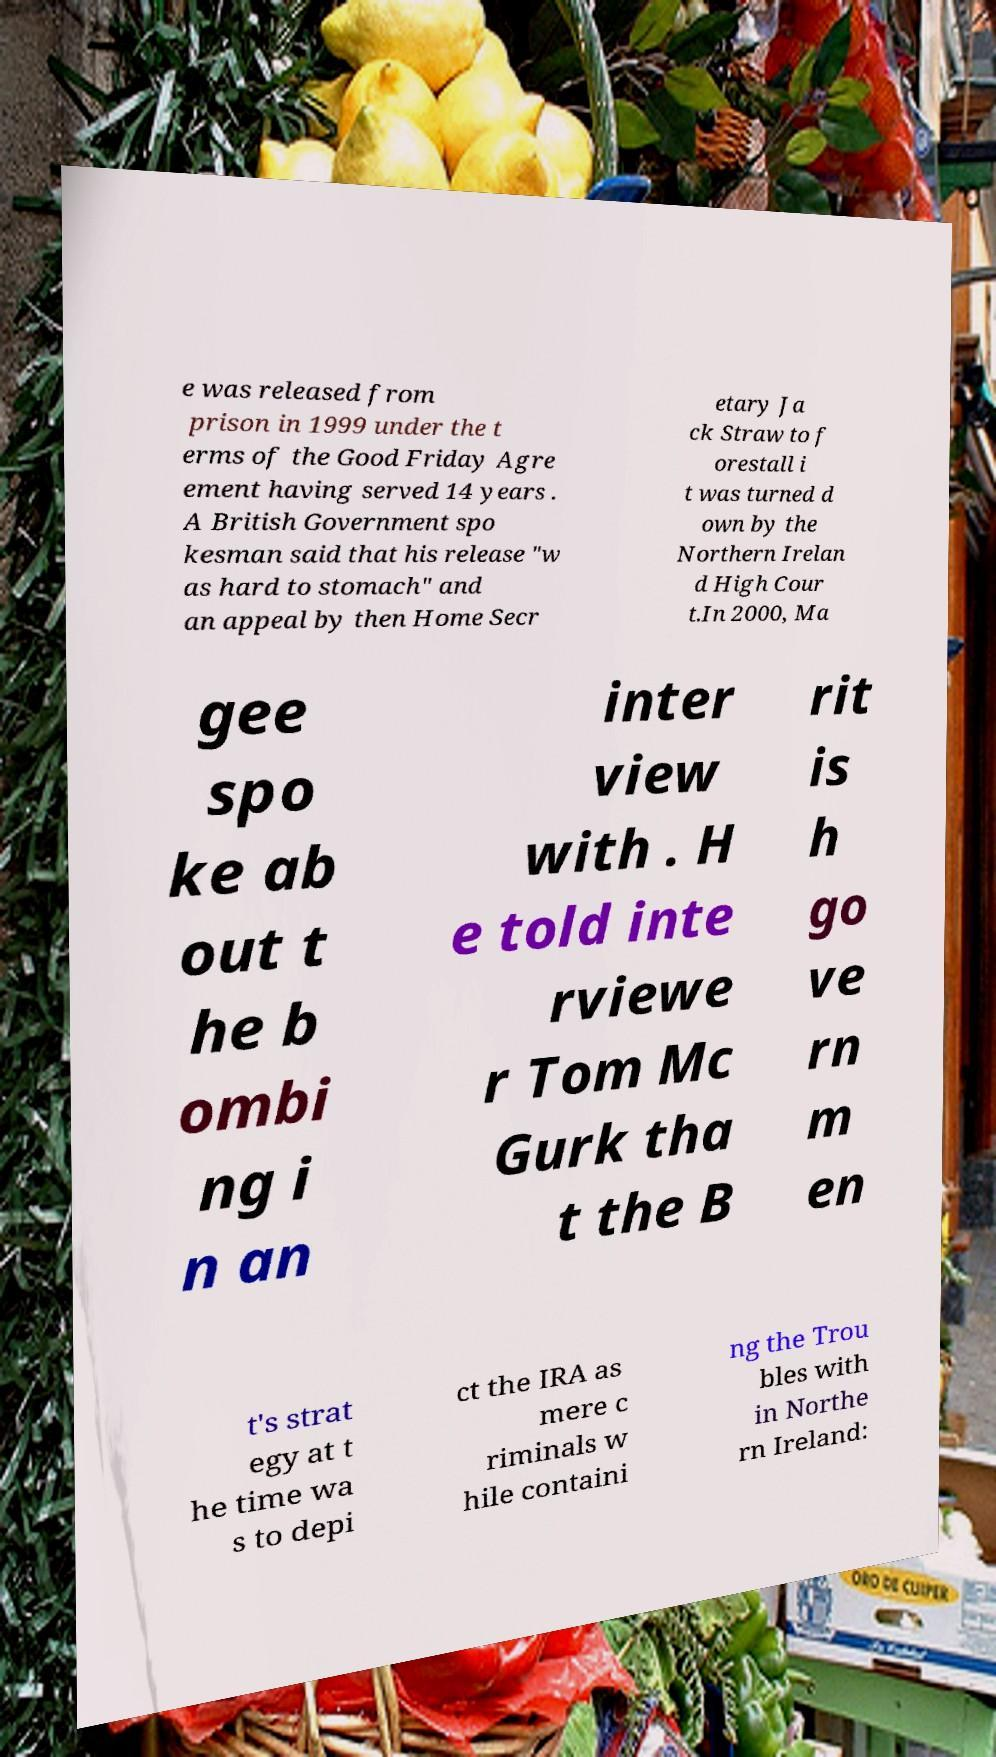Please read and relay the text visible in this image. What does it say? e was released from prison in 1999 under the t erms of the Good Friday Agre ement having served 14 years . A British Government spo kesman said that his release "w as hard to stomach" and an appeal by then Home Secr etary Ja ck Straw to f orestall i t was turned d own by the Northern Irelan d High Cour t.In 2000, Ma gee spo ke ab out t he b ombi ng i n an inter view with . H e told inte rviewe r Tom Mc Gurk tha t the B rit is h go ve rn m en t's strat egy at t he time wa s to depi ct the IRA as mere c riminals w hile containi ng the Trou bles with in Northe rn Ireland: 